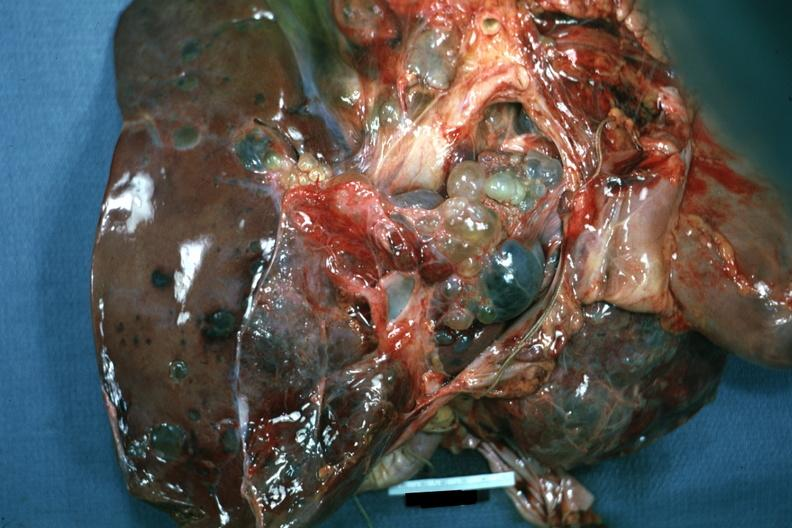what is present?
Answer the question using a single word or phrase. Liver 